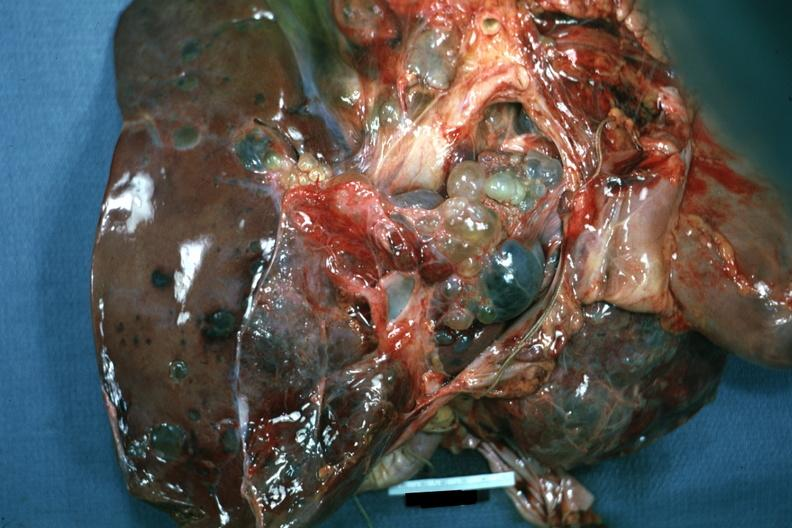what is present?
Answer the question using a single word or phrase. Liver 